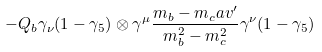<formula> <loc_0><loc_0><loc_500><loc_500>- Q _ { b } \gamma _ { \nu } ( 1 - \gamma _ { 5 } ) \otimes \gamma ^ { \mu } \frac { m _ { b } - m _ { c } \sl a { v } ^ { \prime } } { m _ { b } ^ { 2 } - m _ { c } ^ { 2 } } \gamma ^ { \nu } ( 1 - \gamma _ { 5 } )</formula> 